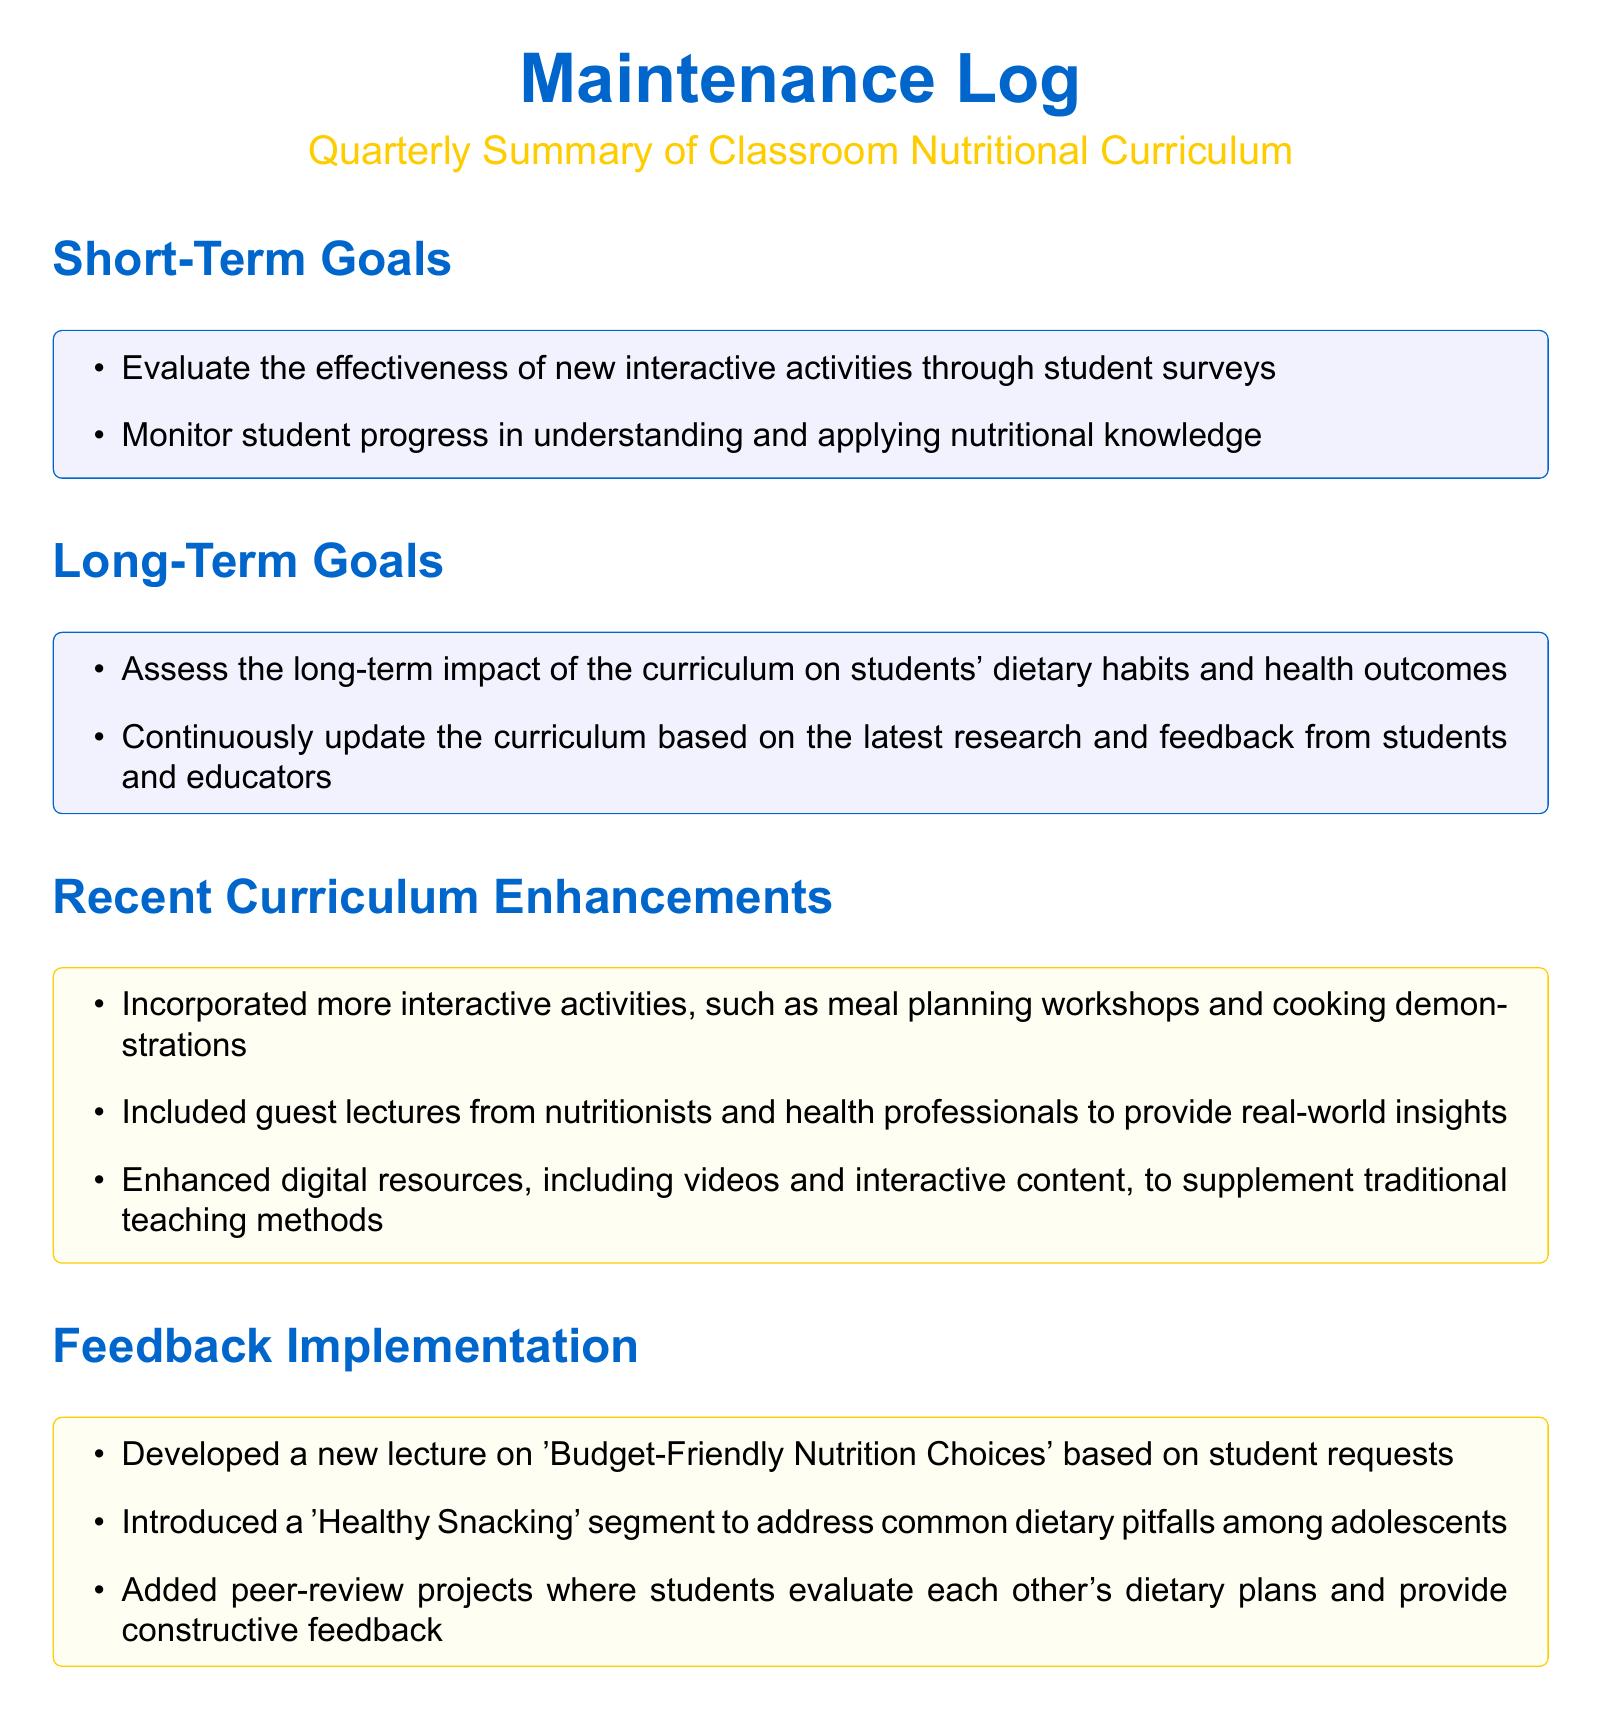What are the short-term goals listed in the document? The short-term goals include evaluating new interactive activities and monitoring student progress.
Answer: Evaluate interactive activities, monitor student progress What is one of the feedback implementations made in the curriculum? The document lists several feedback implementations, one of which is the introduction of a segment on "Healthy Snacking."
Answer: Healthy Snacking segment What are the key outcomes related to knowledge gained? The key outcomes include understanding essential nutrients and identifying long-term health risks.
Answer: Understanding essential nutrients, identifying long-term health risks What long-term goal involves updating the curriculum? One of the long-term goals is to continuously update the curriculum based on research and feedback.
Answer: Continuously update the curriculum What recent enhancement involves guest speakers? The recent enhancement includes guest lectures from nutritionists and health professionals.
Answer: Guest lectures from nutritionists What skill developed is related to meal planning? The document states that students develop the skill in planning balanced meals that meet dietary guidelines.
Answer: Planning balanced meals What behavioral change is emphasized in the outcomes? The document highlights an increased awareness of nutrition's importance in long-term health as a behavioral change.
Answer: Increased awareness of nutrition's importance How many key outcomes are listed in the categories of knowledge gained, skills developed, and behavior changes? The document outlines three main categories of key outcomes, suggesting a total of nine outcomes collectively.
Answer: Nine outcomes What does the curriculum enhance according to recent updates? Recent updates include enhancements to digital resources, indicating an improvement in educational support materials.
Answer: Enhanced digital resources 